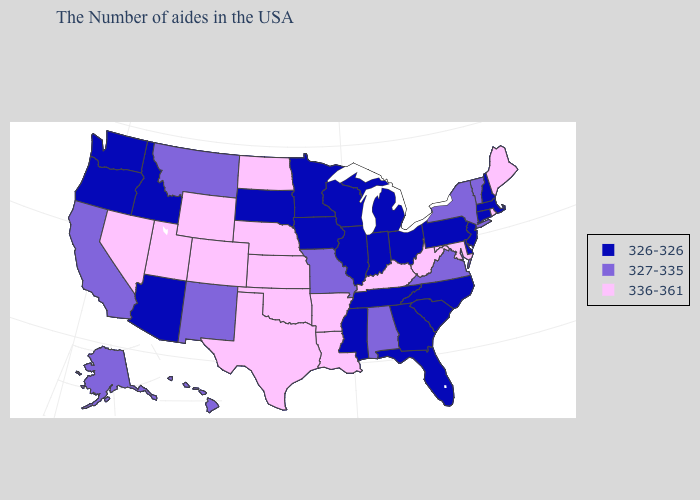Name the states that have a value in the range 326-326?
Keep it brief. Massachusetts, New Hampshire, Connecticut, New Jersey, Delaware, Pennsylvania, North Carolina, South Carolina, Ohio, Florida, Georgia, Michigan, Indiana, Tennessee, Wisconsin, Illinois, Mississippi, Minnesota, Iowa, South Dakota, Arizona, Idaho, Washington, Oregon. Does Montana have a lower value than West Virginia?
Write a very short answer. Yes. Does Colorado have a higher value than Arkansas?
Concise answer only. No. Which states have the lowest value in the West?
Answer briefly. Arizona, Idaho, Washington, Oregon. Name the states that have a value in the range 326-326?
Be succinct. Massachusetts, New Hampshire, Connecticut, New Jersey, Delaware, Pennsylvania, North Carolina, South Carolina, Ohio, Florida, Georgia, Michigan, Indiana, Tennessee, Wisconsin, Illinois, Mississippi, Minnesota, Iowa, South Dakota, Arizona, Idaho, Washington, Oregon. Among the states that border West Virginia , does Kentucky have the lowest value?
Give a very brief answer. No. Name the states that have a value in the range 336-361?
Concise answer only. Maine, Rhode Island, Maryland, West Virginia, Kentucky, Louisiana, Arkansas, Kansas, Nebraska, Oklahoma, Texas, North Dakota, Wyoming, Colorado, Utah, Nevada. Does Maine have the highest value in the USA?
Concise answer only. Yes. Does the first symbol in the legend represent the smallest category?
Keep it brief. Yes. What is the lowest value in the South?
Keep it brief. 326-326. Name the states that have a value in the range 336-361?
Write a very short answer. Maine, Rhode Island, Maryland, West Virginia, Kentucky, Louisiana, Arkansas, Kansas, Nebraska, Oklahoma, Texas, North Dakota, Wyoming, Colorado, Utah, Nevada. How many symbols are there in the legend?
Concise answer only. 3. Name the states that have a value in the range 327-335?
Write a very short answer. Vermont, New York, Virginia, Alabama, Missouri, New Mexico, Montana, California, Alaska, Hawaii. Which states have the lowest value in the MidWest?
Quick response, please. Ohio, Michigan, Indiana, Wisconsin, Illinois, Minnesota, Iowa, South Dakota. Does New Hampshire have a lower value than Indiana?
Give a very brief answer. No. 